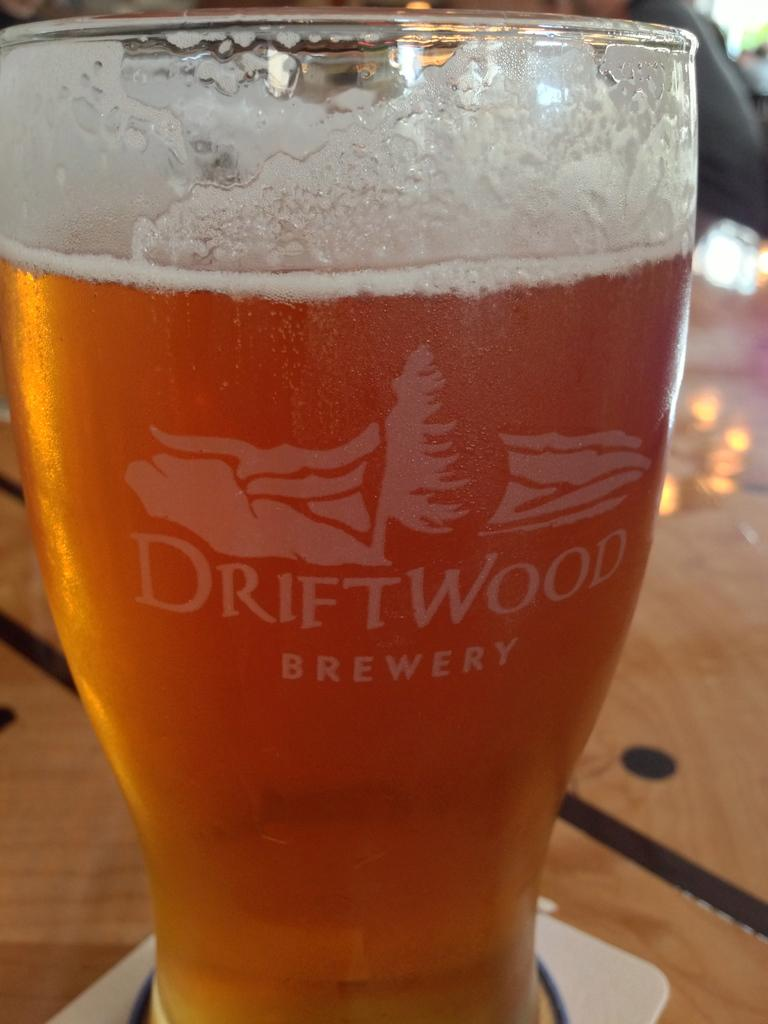What is in the glass that is visible in the image? The glass contains drinks. Are there any distinguishing features on the glass? Yes, there is a logo and writing on the glass. Where is the glass located in the image? The glass is on a surface. Where is the nest located in the image? There is no nest present in the image. Can you describe the ball that is visible in the image? There is no ball present in the image. 